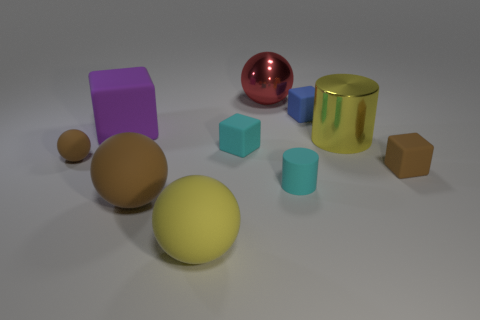What shape is the large matte thing that is the same color as the small sphere?
Provide a succinct answer. Sphere. The large purple thing that is the same material as the brown block is what shape?
Keep it short and to the point. Cube. There is a large metallic object right of the small blue rubber cube; is its color the same as the big object that is in front of the big brown object?
Offer a terse response. Yes. There is a brown object behind the tiny brown matte thing that is on the right side of the metallic thing that is behind the tiny blue thing; how big is it?
Provide a short and direct response. Small. There is a object that is to the left of the large brown thing and in front of the big rubber cube; what is its shape?
Give a very brief answer. Sphere. Is the number of tiny blue matte objects on the right side of the small blue cube the same as the number of big things that are behind the tiny ball?
Provide a succinct answer. No. Are there any tiny gray cubes made of the same material as the large yellow sphere?
Offer a very short reply. No. Does the brown thing that is on the right side of the big yellow matte object have the same material as the small blue cube?
Ensure brevity in your answer.  Yes. How big is the sphere that is both on the right side of the purple matte thing and behind the large brown object?
Your answer should be compact. Large. What color is the large matte cube?
Your answer should be compact. Purple. 